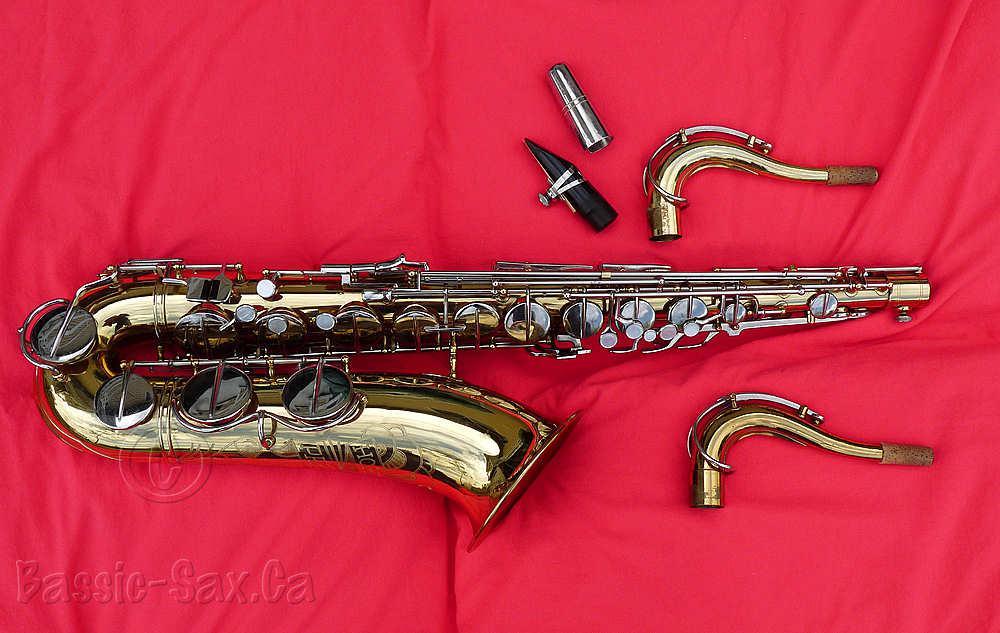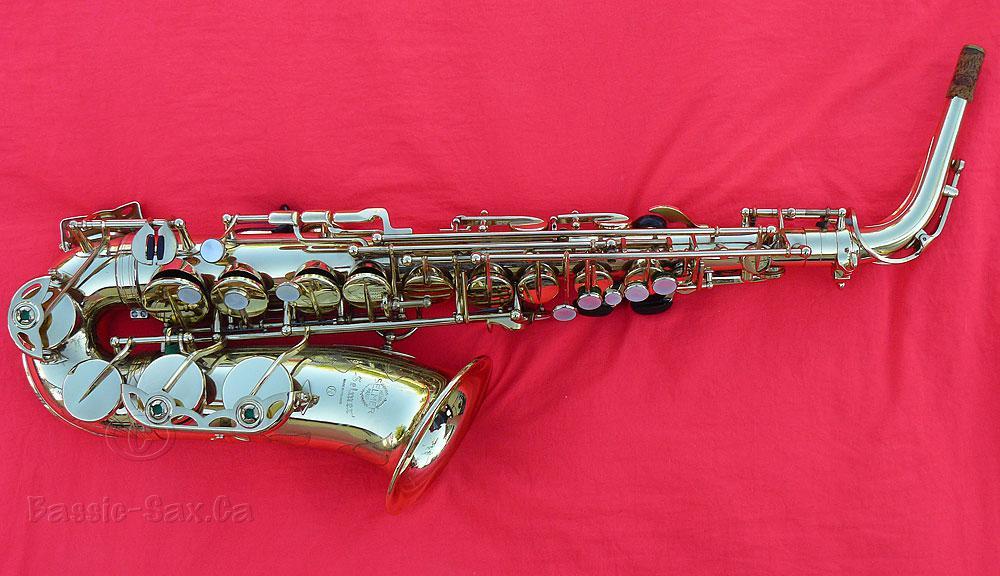The first image is the image on the left, the second image is the image on the right. Assess this claim about the two images: "Saxophones displayed in the left and right images are positioned in the same way and facing same direction.". Correct or not? Answer yes or no. Yes. The first image is the image on the left, the second image is the image on the right. Evaluate the accuracy of this statement regarding the images: "The saxophones are positioned in the same way on the red blanket.". Is it true? Answer yes or no. Yes. 